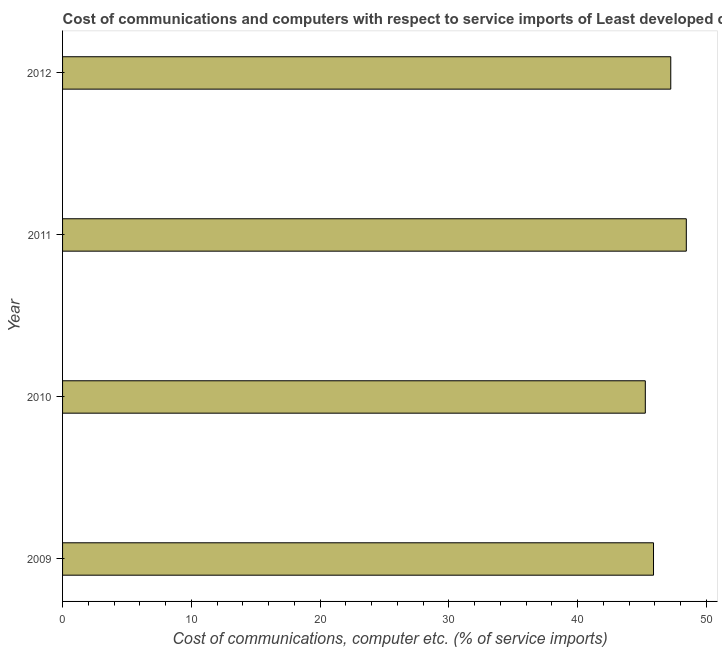What is the title of the graph?
Give a very brief answer. Cost of communications and computers with respect to service imports of Least developed countries. What is the label or title of the X-axis?
Provide a succinct answer. Cost of communications, computer etc. (% of service imports). What is the label or title of the Y-axis?
Make the answer very short. Year. What is the cost of communications and computer in 2011?
Make the answer very short. 48.43. Across all years, what is the maximum cost of communications and computer?
Offer a terse response. 48.43. Across all years, what is the minimum cost of communications and computer?
Give a very brief answer. 45.25. In which year was the cost of communications and computer maximum?
Make the answer very short. 2011. In which year was the cost of communications and computer minimum?
Keep it short and to the point. 2010. What is the sum of the cost of communications and computer?
Your answer should be compact. 186.8. What is the difference between the cost of communications and computer in 2011 and 2012?
Keep it short and to the point. 1.21. What is the average cost of communications and computer per year?
Your answer should be very brief. 46.7. What is the median cost of communications and computer?
Your response must be concise. 46.56. In how many years, is the cost of communications and computer greater than 8 %?
Your answer should be compact. 4. Do a majority of the years between 2009 and 2012 (inclusive) have cost of communications and computer greater than 14 %?
Keep it short and to the point. Yes. Is the difference between the cost of communications and computer in 2010 and 2012 greater than the difference between any two years?
Ensure brevity in your answer.  No. What is the difference between the highest and the second highest cost of communications and computer?
Your response must be concise. 1.21. Is the sum of the cost of communications and computer in 2009 and 2010 greater than the maximum cost of communications and computer across all years?
Your answer should be very brief. Yes. What is the difference between the highest and the lowest cost of communications and computer?
Offer a terse response. 3.18. In how many years, is the cost of communications and computer greater than the average cost of communications and computer taken over all years?
Give a very brief answer. 2. Are all the bars in the graph horizontal?
Provide a short and direct response. Yes. What is the difference between two consecutive major ticks on the X-axis?
Your answer should be compact. 10. What is the Cost of communications, computer etc. (% of service imports) in 2009?
Your answer should be very brief. 45.89. What is the Cost of communications, computer etc. (% of service imports) in 2010?
Make the answer very short. 45.25. What is the Cost of communications, computer etc. (% of service imports) of 2011?
Offer a very short reply. 48.43. What is the Cost of communications, computer etc. (% of service imports) of 2012?
Keep it short and to the point. 47.23. What is the difference between the Cost of communications, computer etc. (% of service imports) in 2009 and 2010?
Provide a short and direct response. 0.64. What is the difference between the Cost of communications, computer etc. (% of service imports) in 2009 and 2011?
Provide a short and direct response. -2.55. What is the difference between the Cost of communications, computer etc. (% of service imports) in 2009 and 2012?
Give a very brief answer. -1.34. What is the difference between the Cost of communications, computer etc. (% of service imports) in 2010 and 2011?
Your response must be concise. -3.18. What is the difference between the Cost of communications, computer etc. (% of service imports) in 2010 and 2012?
Your response must be concise. -1.98. What is the difference between the Cost of communications, computer etc. (% of service imports) in 2011 and 2012?
Offer a very short reply. 1.21. What is the ratio of the Cost of communications, computer etc. (% of service imports) in 2009 to that in 2011?
Your answer should be compact. 0.95. What is the ratio of the Cost of communications, computer etc. (% of service imports) in 2010 to that in 2011?
Keep it short and to the point. 0.93. What is the ratio of the Cost of communications, computer etc. (% of service imports) in 2010 to that in 2012?
Offer a very short reply. 0.96. What is the ratio of the Cost of communications, computer etc. (% of service imports) in 2011 to that in 2012?
Your response must be concise. 1.03. 